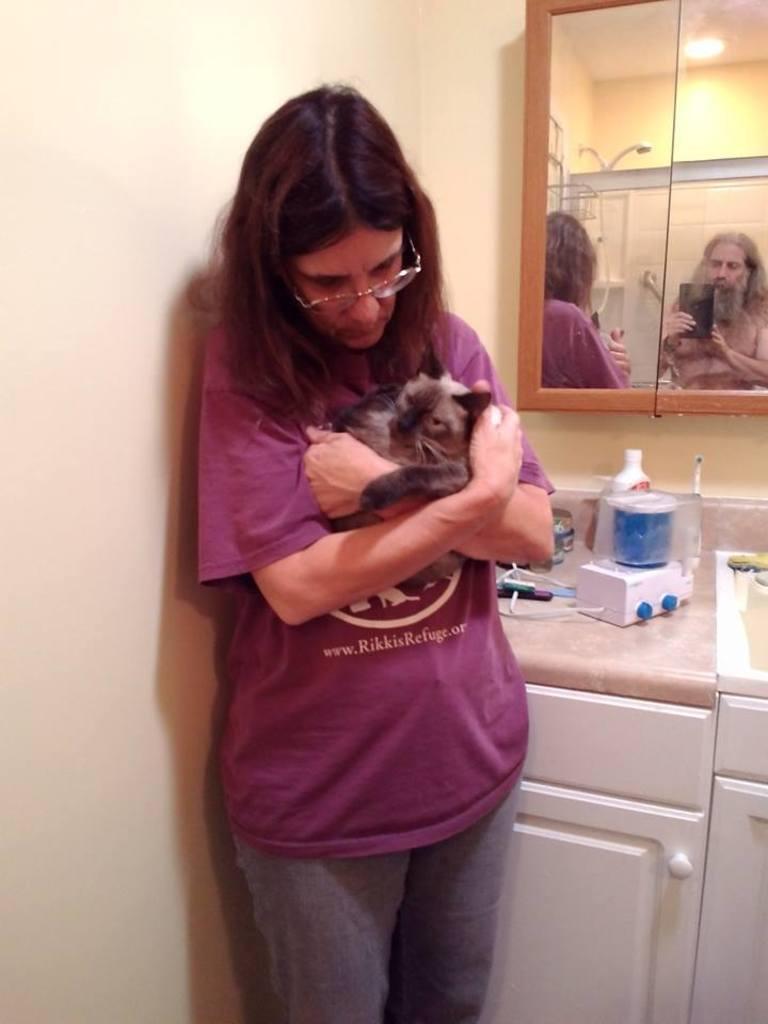Describe this image in one or two sentences. In this image we can see a woman is standing and holding a cat in her hands, and at back here is the mirror, and here are some objects on the table, and here is the wall. 